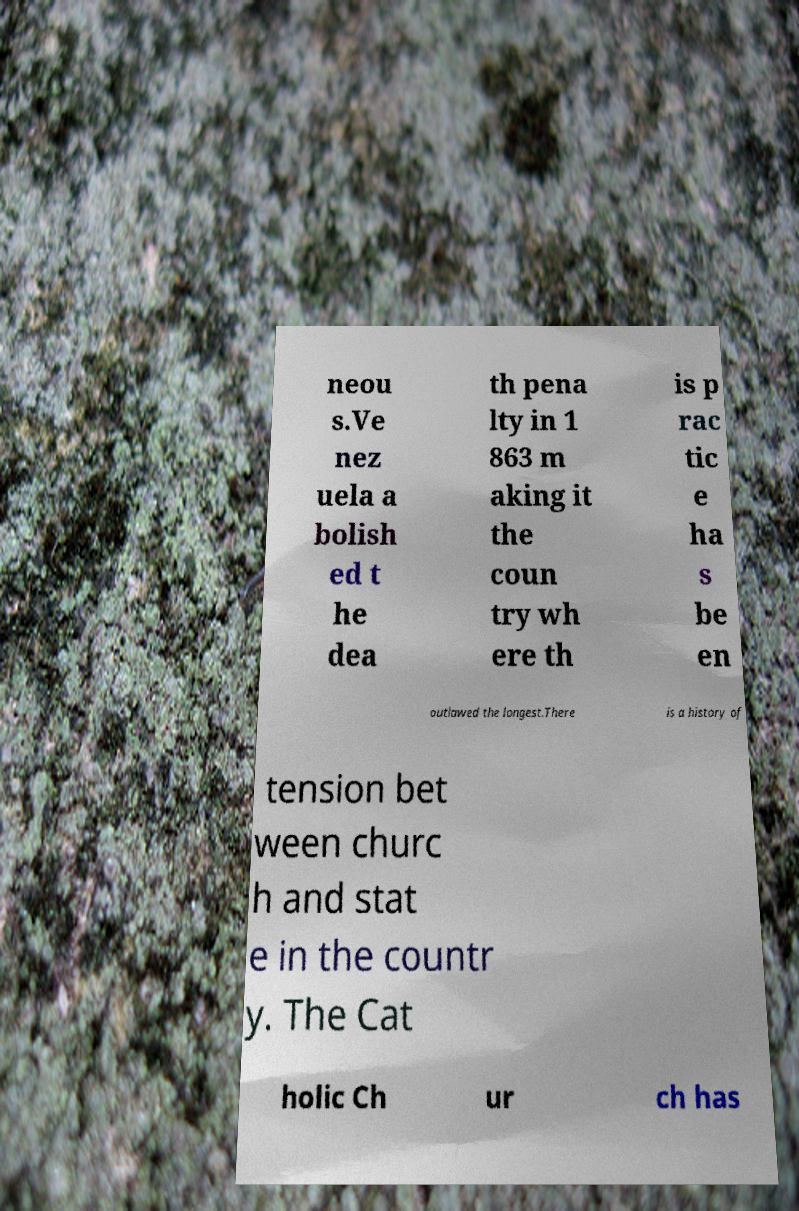Please read and relay the text visible in this image. What does it say? neou s.Ve nez uela a bolish ed t he dea th pena lty in 1 863 m aking it the coun try wh ere th is p rac tic e ha s be en outlawed the longest.There is a history of tension bet ween churc h and stat e in the countr y. The Cat holic Ch ur ch has 